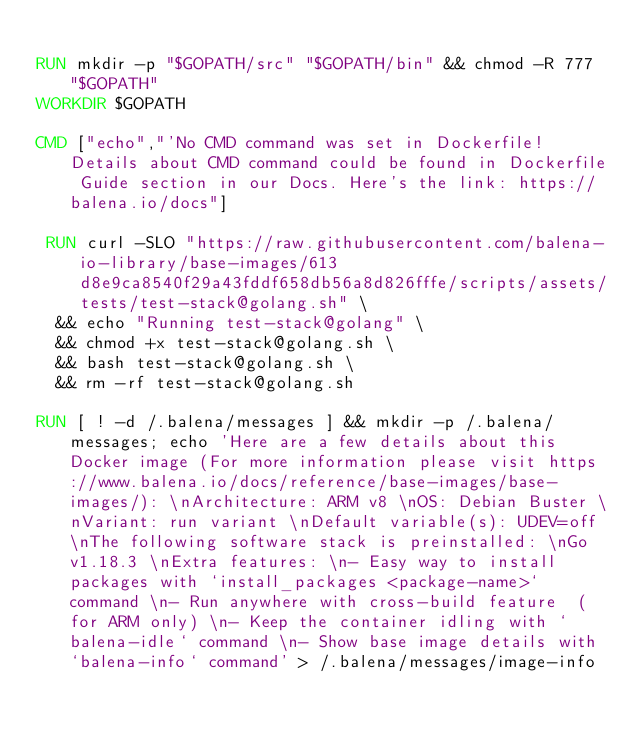<code> <loc_0><loc_0><loc_500><loc_500><_Dockerfile_>
RUN mkdir -p "$GOPATH/src" "$GOPATH/bin" && chmod -R 777 "$GOPATH"
WORKDIR $GOPATH

CMD ["echo","'No CMD command was set in Dockerfile! Details about CMD command could be found in Dockerfile Guide section in our Docs. Here's the link: https://balena.io/docs"]

 RUN curl -SLO "https://raw.githubusercontent.com/balena-io-library/base-images/613d8e9ca8540f29a43fddf658db56a8d826fffe/scripts/assets/tests/test-stack@golang.sh" \
  && echo "Running test-stack@golang" \
  && chmod +x test-stack@golang.sh \
  && bash test-stack@golang.sh \
  && rm -rf test-stack@golang.sh 

RUN [ ! -d /.balena/messages ] && mkdir -p /.balena/messages; echo 'Here are a few details about this Docker image (For more information please visit https://www.balena.io/docs/reference/base-images/base-images/): \nArchitecture: ARM v8 \nOS: Debian Buster \nVariant: run variant \nDefault variable(s): UDEV=off \nThe following software stack is preinstalled: \nGo v1.18.3 \nExtra features: \n- Easy way to install packages with `install_packages <package-name>` command \n- Run anywhere with cross-build feature  (for ARM only) \n- Keep the container idling with `balena-idle` command \n- Show base image details with `balena-info` command' > /.balena/messages/image-info</code> 